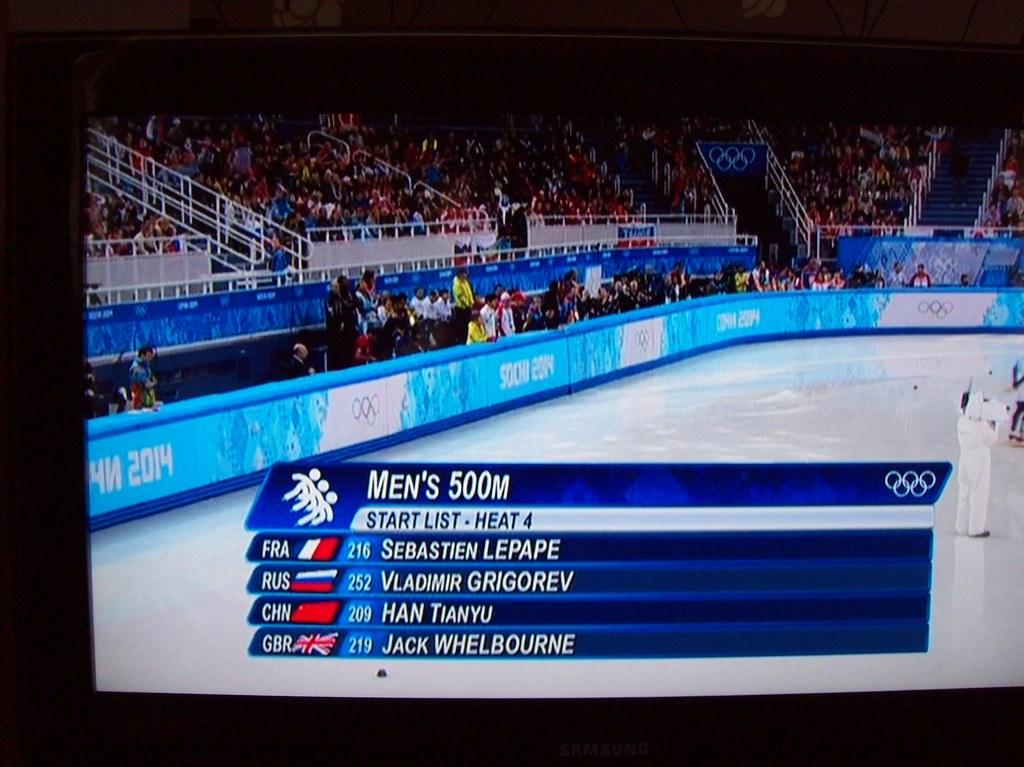<image>
Offer a succinct explanation of the picture presented. At a ice rink, the men's 500 meter start list is shown. 